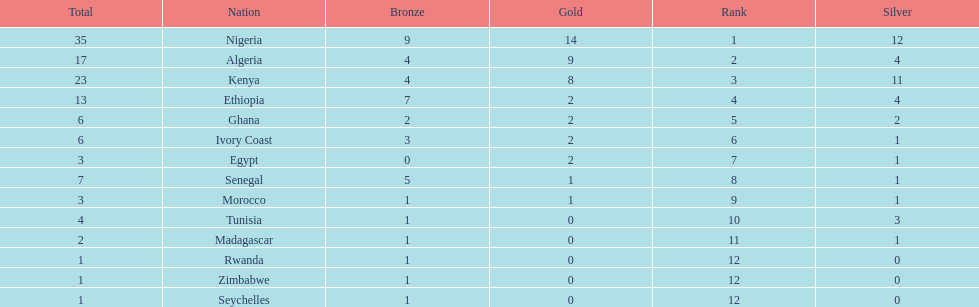How many medals did senegal win? 7. 